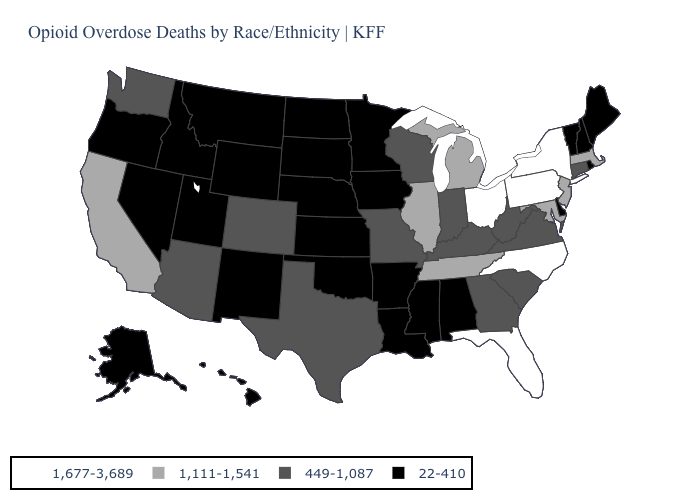Name the states that have a value in the range 1,677-3,689?
Concise answer only. Florida, New York, North Carolina, Ohio, Pennsylvania. What is the value of Massachusetts?
Give a very brief answer. 1,111-1,541. What is the lowest value in the USA?
Quick response, please. 22-410. Name the states that have a value in the range 1,111-1,541?
Keep it brief. California, Illinois, Maryland, Massachusetts, Michigan, New Jersey, Tennessee. Name the states that have a value in the range 449-1,087?
Answer briefly. Arizona, Colorado, Connecticut, Georgia, Indiana, Kentucky, Missouri, South Carolina, Texas, Virginia, Washington, West Virginia, Wisconsin. What is the lowest value in the USA?
Write a very short answer. 22-410. Which states have the lowest value in the MidWest?
Answer briefly. Iowa, Kansas, Minnesota, Nebraska, North Dakota, South Dakota. Name the states that have a value in the range 1,677-3,689?
Be succinct. Florida, New York, North Carolina, Ohio, Pennsylvania. Does Mississippi have the same value as Maine?
Be succinct. Yes. Name the states that have a value in the range 449-1,087?
Quick response, please. Arizona, Colorado, Connecticut, Georgia, Indiana, Kentucky, Missouri, South Carolina, Texas, Virginia, Washington, West Virginia, Wisconsin. What is the lowest value in states that border Alabama?
Keep it brief. 22-410. What is the highest value in states that border Michigan?
Answer briefly. 1,677-3,689. Is the legend a continuous bar?
Give a very brief answer. No. What is the value of Arizona?
Keep it brief. 449-1,087. Name the states that have a value in the range 1,677-3,689?
Write a very short answer. Florida, New York, North Carolina, Ohio, Pennsylvania. 